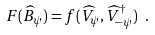Convert formula to latex. <formula><loc_0><loc_0><loc_500><loc_500>F ( \widehat { B } _ { \psi } ) = f ( \widehat { V } _ { \psi } , \widehat { V } _ { - \psi } ^ { \dagger } ) \ .</formula> 